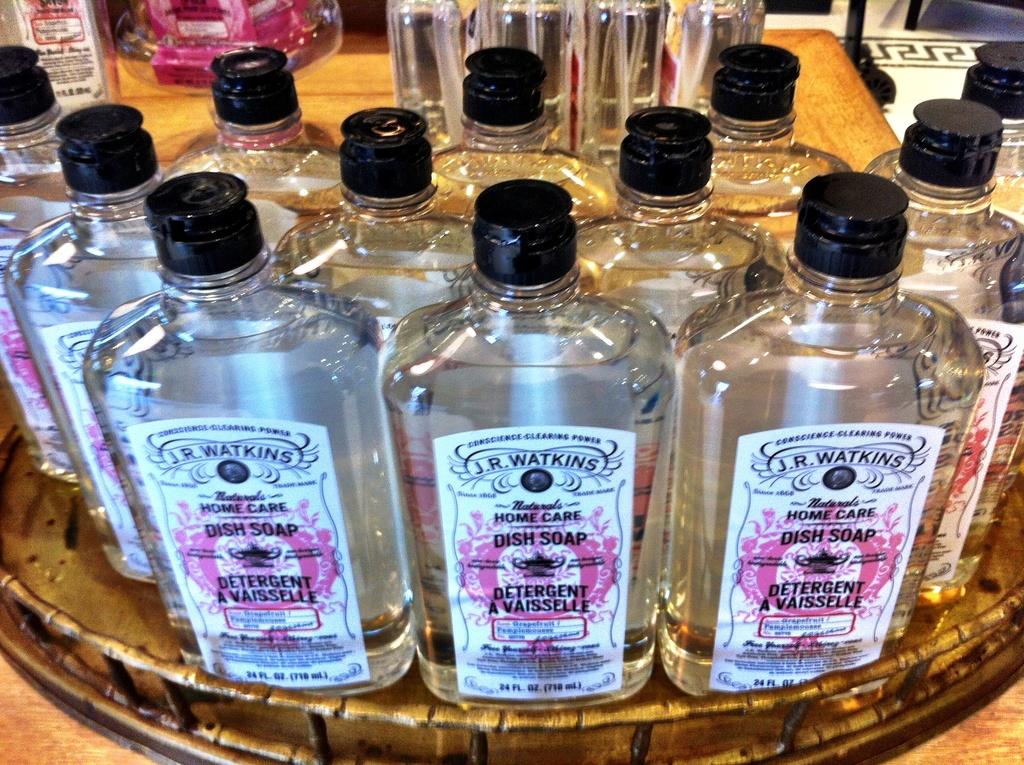Who's name is printed at the top of this "dish soap" label?
Your answer should be very brief. J.r. watkins. What type of soap is this?
Your answer should be compact. Dish soap. 